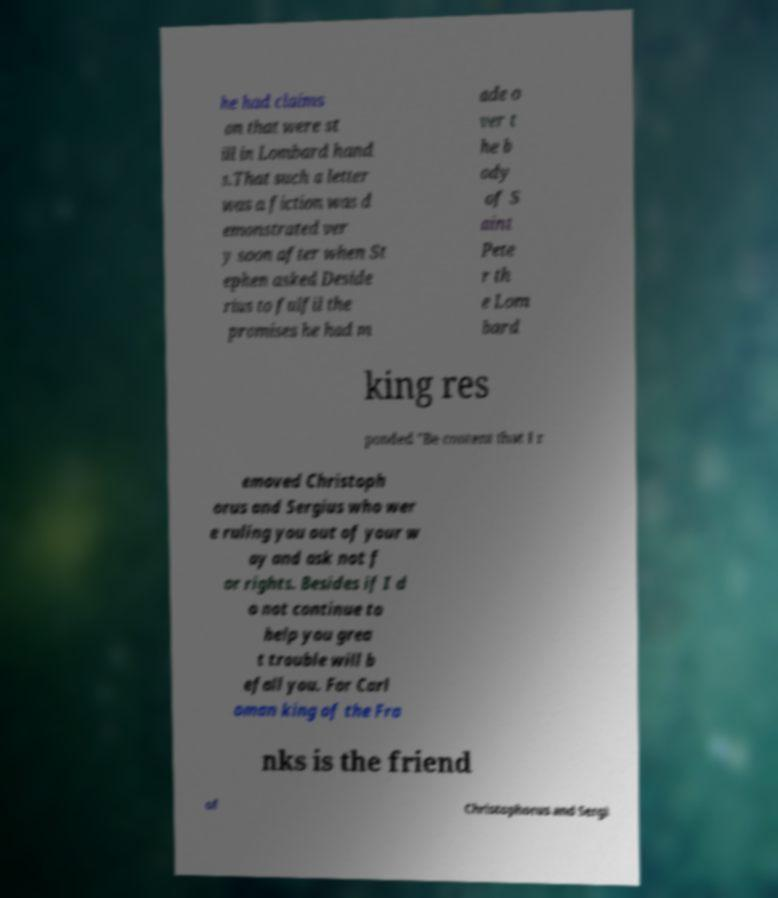Could you assist in decoding the text presented in this image and type it out clearly? he had claims on that were st ill in Lombard hand s.That such a letter was a fiction was d emonstrated ver y soon after when St ephen asked Deside rius to fulfil the promises he had m ade o ver t he b ody of S aint Pete r th e Lom bard king res ponded ”Be content that I r emoved Christoph orus and Sergius who wer e ruling you out of your w ay and ask not f or rights. Besides if I d o not continue to help you grea t trouble will b efall you. For Carl oman king of the Fra nks is the friend of Christophorus and Sergi 